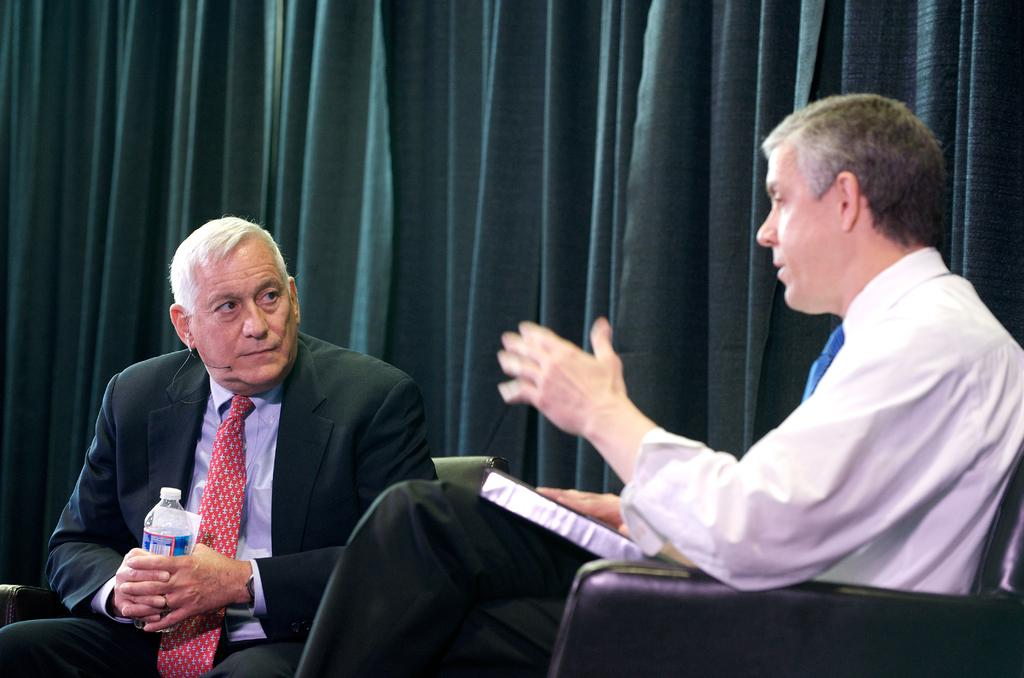How many people are in the image? There are two people in the image. What are the people doing in the image? The people are sitting on chairs. What are the people holding in their hands? The people are holding objects in their hands. What can be seen in the background of the image? There is a curtain visible in the background of the image. What type of bone can be seen in the image? There is no bone present in the image. What kind of plastic material is visible in the image? There is no plastic material visible in the image. 